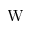Convert formula to latex. <formula><loc_0><loc_0><loc_500><loc_500>W</formula> 